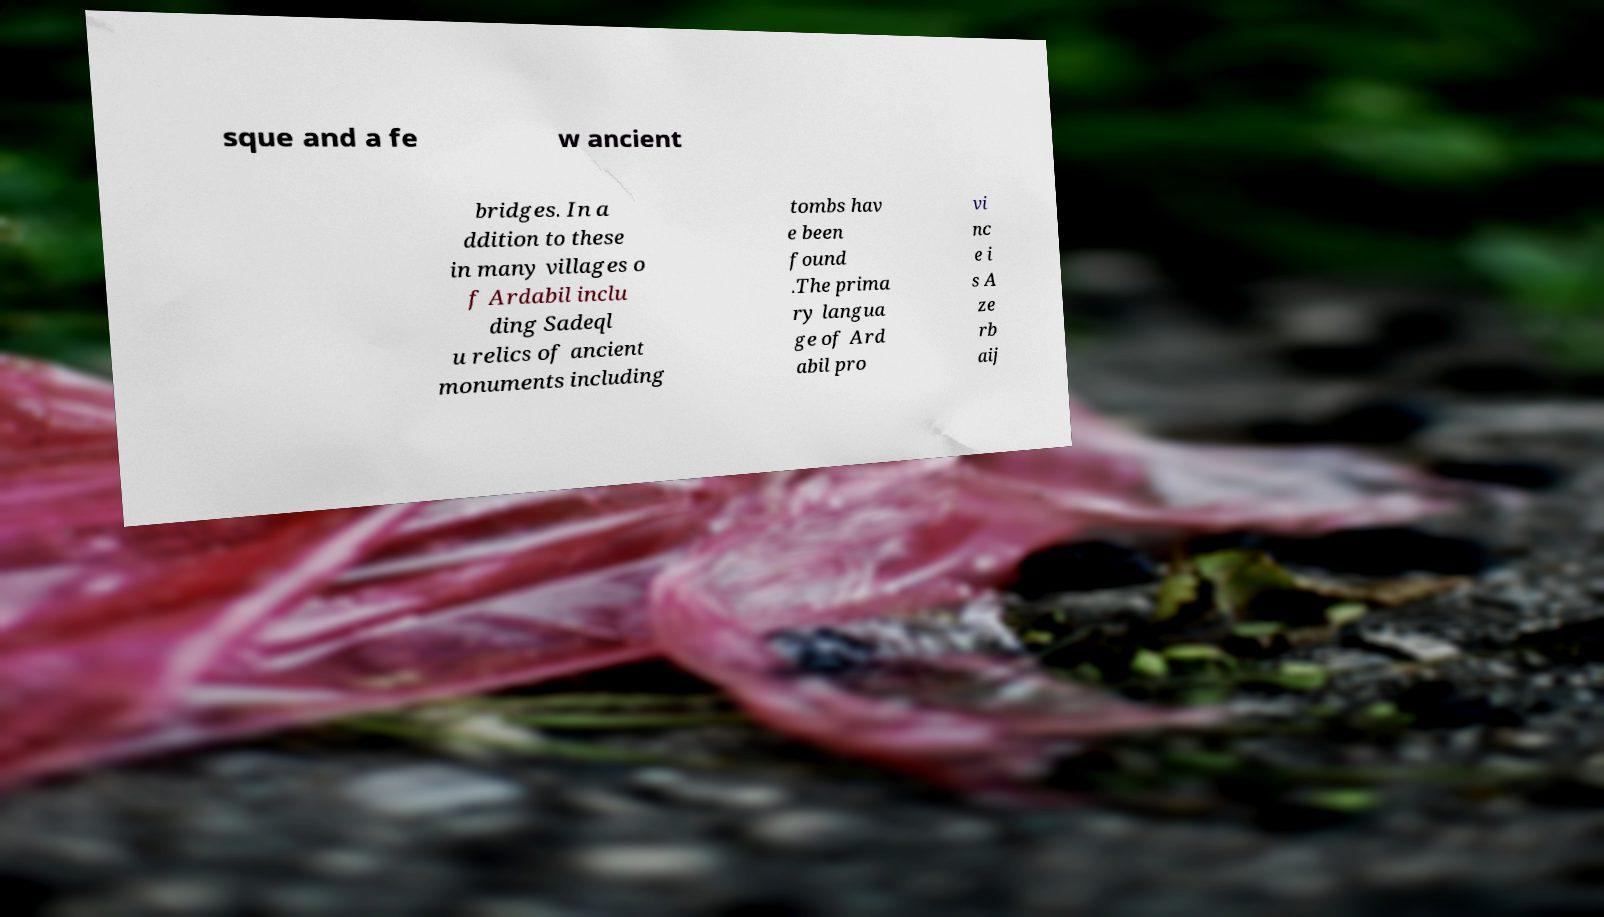There's text embedded in this image that I need extracted. Can you transcribe it verbatim? sque and a fe w ancient bridges. In a ddition to these in many villages o f Ardabil inclu ding Sadeql u relics of ancient monuments including tombs hav e been found .The prima ry langua ge of Ard abil pro vi nc e i s A ze rb aij 